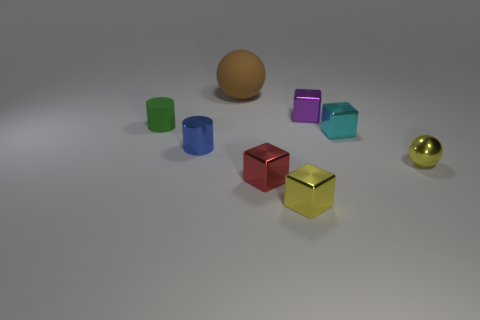Which object in the image is the closest to the camera? The object closest to the camera is the brown sphere at the forefront of the image.  Is there any object that stands out due to its brightness or reflectiveness? Yes, the bright, reflective gold sphere on the far right stands out due to its shininess and the way it catches the light. 